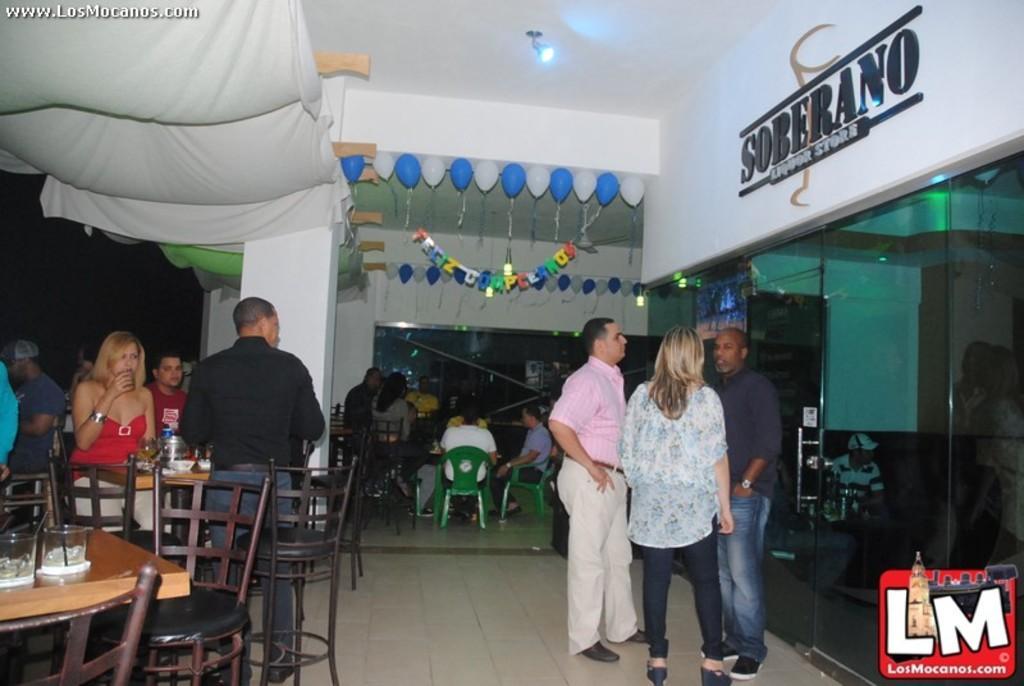How would you summarize this image in a sentence or two? This image consists of many persons. It looks like a restaurant. On the left, there are chairs and tables. At the top. there is a white cloth. At the bottom, there is a floor. On the right, there is a glass door. 